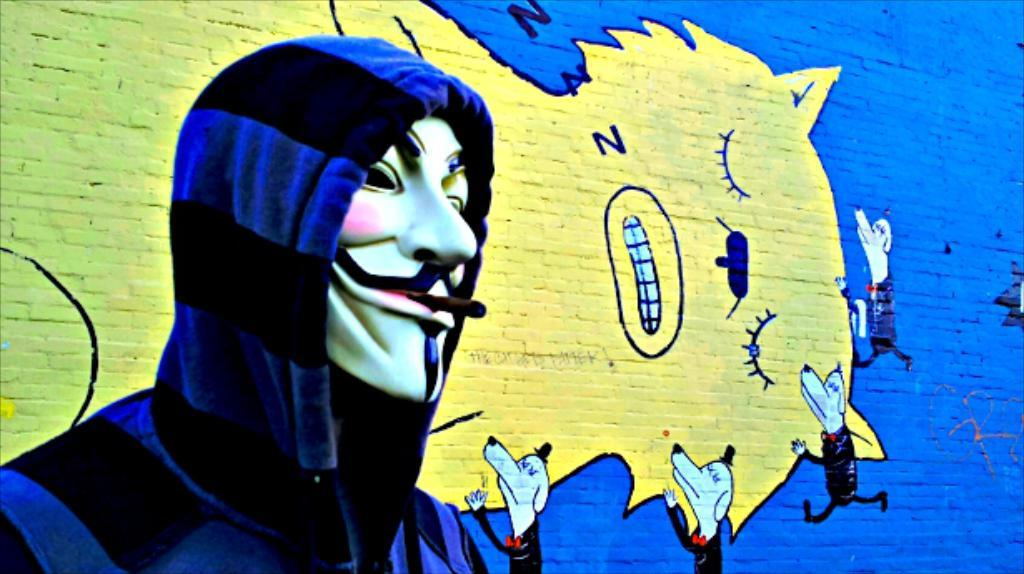What is the person in the image wearing on their face? The person in the image is wearing a mask. What can be seen on the wall in the image? There are paintings of animals on the wall in the image. What type of key is hanging from the locket in the image? There is no key or locket present in the image; it only features a person wearing a mask and paintings of animals on the wall. 